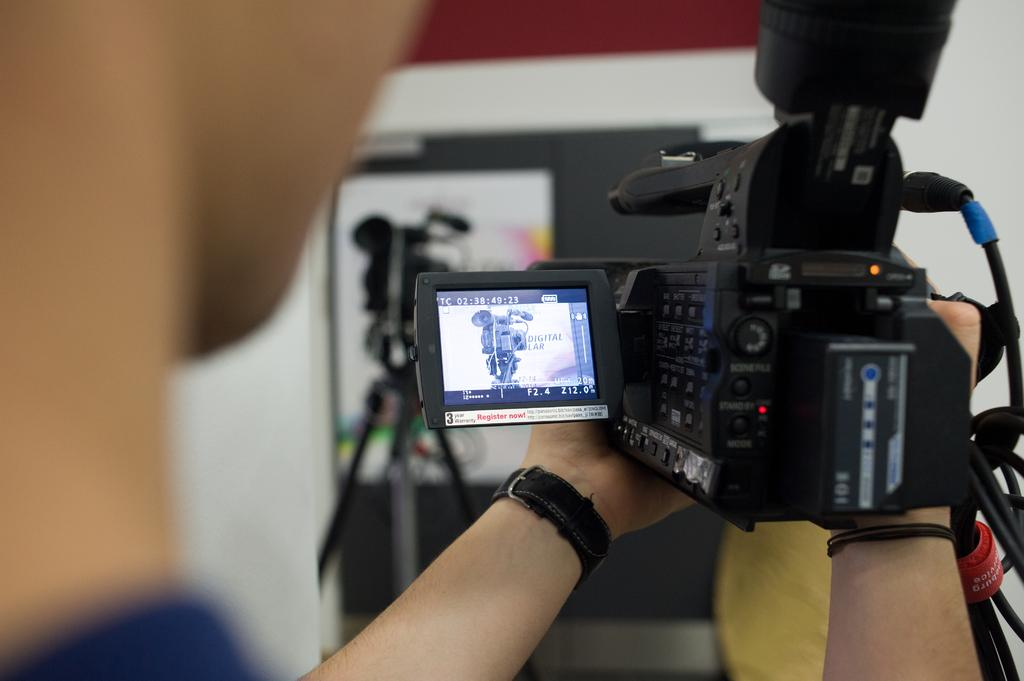What is the main subject in the foreground of the image? There is a person in the foreground of the image. What is the person holding in the image? The person is holding a camera. What other camera can be seen in the image? There is another camera in the background of the image. What else is present in the background of the image? There is a board in the background of the image. How does the system blow air in the image? There is no system or blowing of air present in the image. 